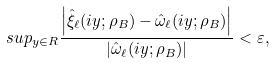Convert formula to latex. <formula><loc_0><loc_0><loc_500><loc_500>s u p _ { y \in R } \frac { \left | \hat { \xi } _ { \ell } ( i y ; \rho _ { B } ) - \hat { \omega } _ { \ell } ( i y ; \rho _ { B } ) \right | } { \left | \hat { \omega } _ { \ell } ( i y ; \rho _ { B } ) \right | } < \varepsilon ,</formula> 